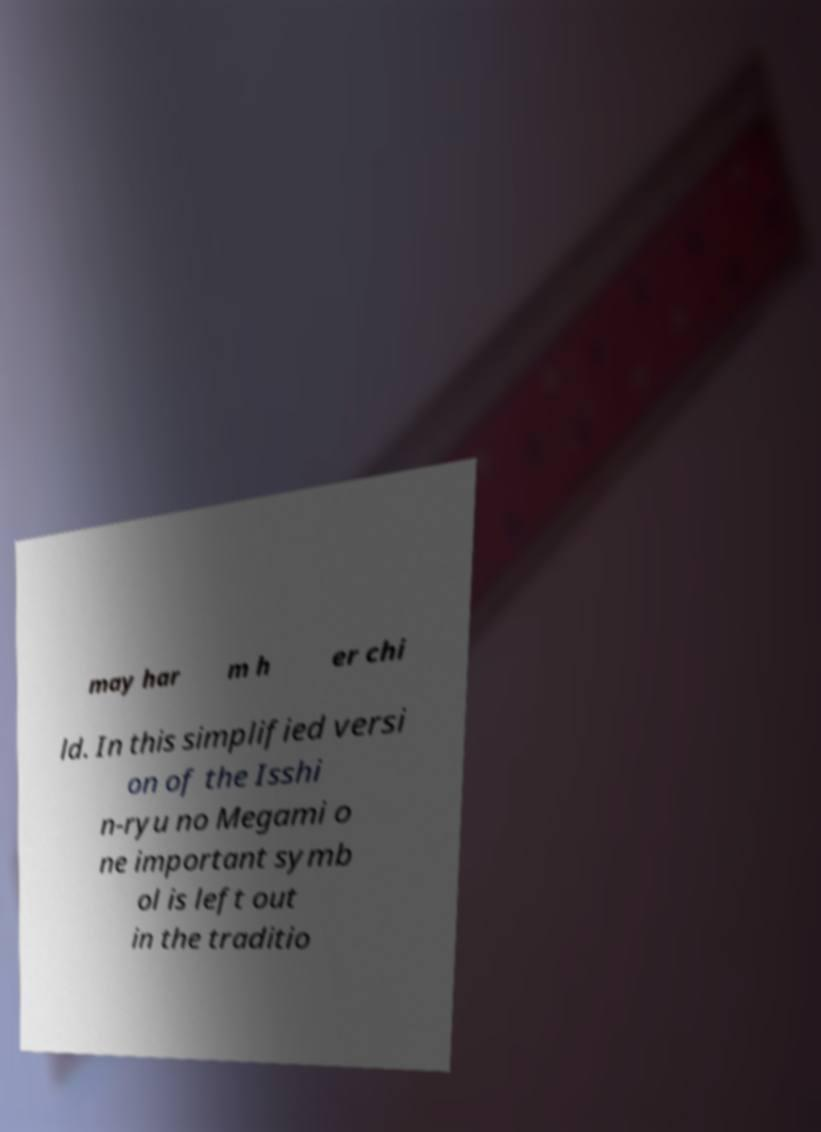Could you assist in decoding the text presented in this image and type it out clearly? may har m h er chi ld. In this simplified versi on of the Isshi n-ryu no Megami o ne important symb ol is left out in the traditio 